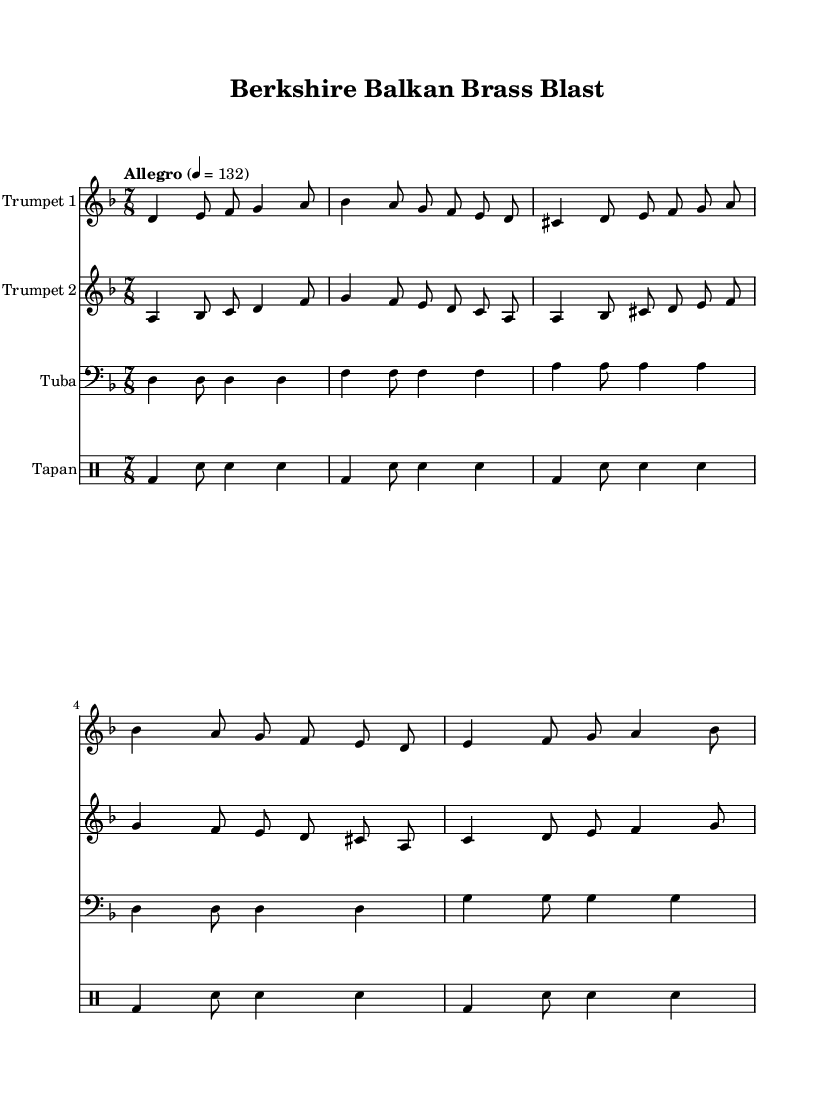What is the key signature of this music? The key signature can be found at the beginning of the staff, where there are two flat symbols indicating B flat and E flat. Thus, this piece is in the key of D minor.
Answer: D minor What is the time signature of this music? The time signature is displayed at the beginning of the sheet music as a fraction, where the top number is 7 and the bottom number is 8. This indicates that there are seven eighth notes per measure.
Answer: 7/8 What is the tempo marking for this piece? The tempo indication is shown in the score, with "Allegro" followed by a metronome marking of 132 beats per minute. Allegro suggests a fast tempo.
Answer: Allegro 4 = 132 How many measures are there in the trumpet parts? Each trumpet part has a consistent number of measures; counting each line reveals there are five measures for both Trumpet 1 and Trumpet 2.
Answer: 5 What is the main rhythmic pattern for the drums? The drum pattern established is based on the bass drum and snare, a recurring motif demonstrated in each line with a combination of bass and snare hits, which represent the common 7/8 rhythm.
Answer: Bass drum and snare Which instrument plays the lowest part in this arrangement? The instrument with the lowest pitch is the tuba, which is notated in the bass clef and has a deeper sound compared to the trumpets written in treble clef.
Answer: Tuba What type of ensemble is typical for Balkan brass music? Balkan brass music typically features a brass ensemble, often including trumpets, tubas, and drums, focusing on vibrant and energetic rhythms, as seen in this score with its brass instrumentation.
Answer: Brass ensemble 